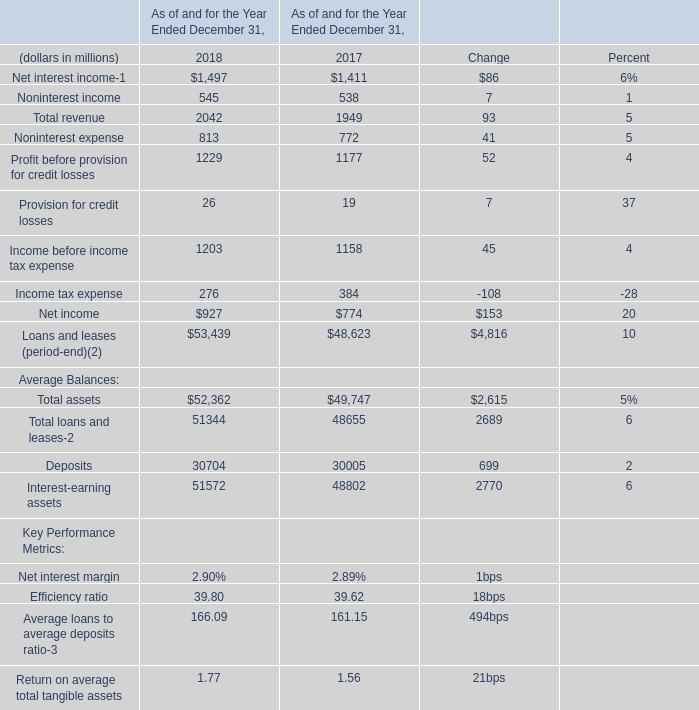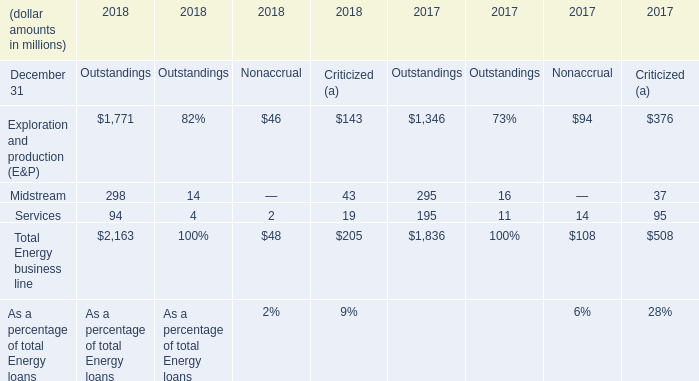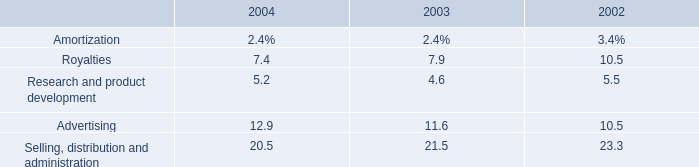What was the total amount of the Average Balances in the years where Net interest income is greater than 1450? (in million) 
Computations: (((52362 + 51344) + 30704) + 51572)
Answer: 185982.0. 